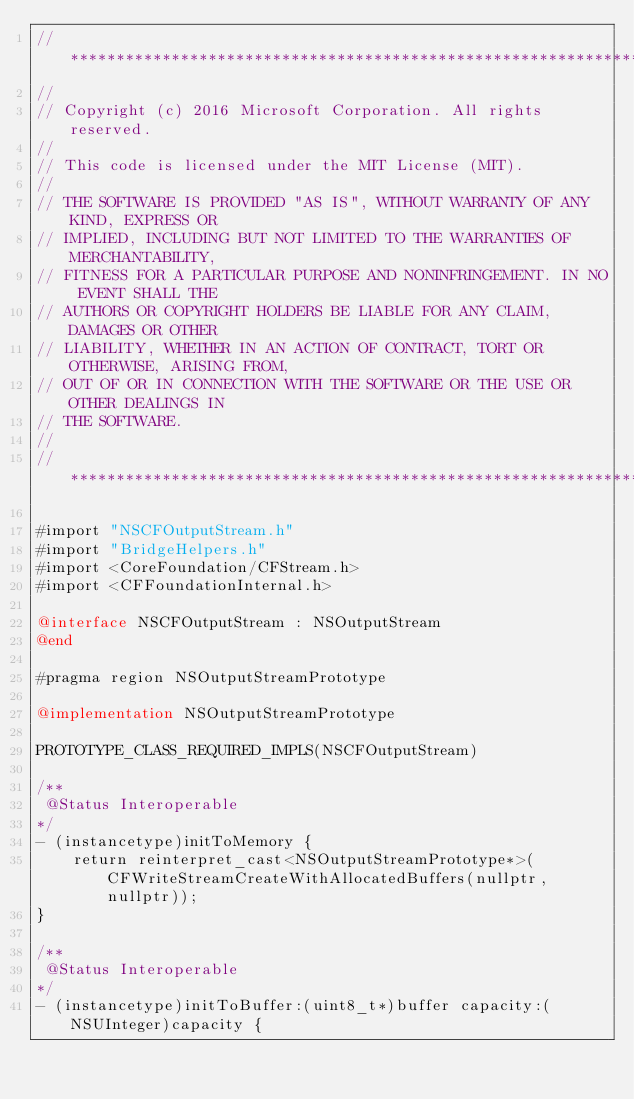<code> <loc_0><loc_0><loc_500><loc_500><_ObjectiveC_>//******************************************************************************
//
// Copyright (c) 2016 Microsoft Corporation. All rights reserved.
//
// This code is licensed under the MIT License (MIT).
//
// THE SOFTWARE IS PROVIDED "AS IS", WITHOUT WARRANTY OF ANY KIND, EXPRESS OR
// IMPLIED, INCLUDING BUT NOT LIMITED TO THE WARRANTIES OF MERCHANTABILITY,
// FITNESS FOR A PARTICULAR PURPOSE AND NONINFRINGEMENT. IN NO EVENT SHALL THE
// AUTHORS OR COPYRIGHT HOLDERS BE LIABLE FOR ANY CLAIM, DAMAGES OR OTHER
// LIABILITY, WHETHER IN AN ACTION OF CONTRACT, TORT OR OTHERWISE, ARISING FROM,
// OUT OF OR IN CONNECTION WITH THE SOFTWARE OR THE USE OR OTHER DEALINGS IN
// THE SOFTWARE.
//
//******************************************************************************

#import "NSCFOutputStream.h"
#import "BridgeHelpers.h"
#import <CoreFoundation/CFStream.h>
#import <CFFoundationInternal.h>

@interface NSCFOutputStream : NSOutputStream
@end

#pragma region NSOutputStreamPrototype

@implementation NSOutputStreamPrototype

PROTOTYPE_CLASS_REQUIRED_IMPLS(NSCFOutputStream)

/**
 @Status Interoperable
*/
- (instancetype)initToMemory {
    return reinterpret_cast<NSOutputStreamPrototype*>(CFWriteStreamCreateWithAllocatedBuffers(nullptr, nullptr));
}

/**
 @Status Interoperable
*/
- (instancetype)initToBuffer:(uint8_t*)buffer capacity:(NSUInteger)capacity {</code> 